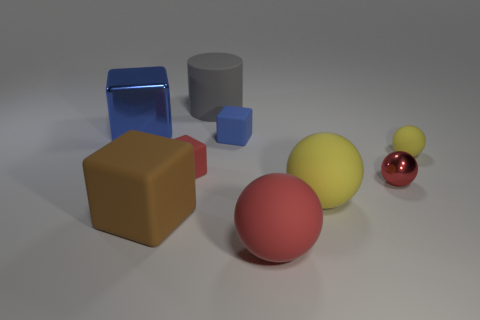Subtract all red metallic spheres. How many spheres are left? 3 Add 1 big blue objects. How many objects exist? 10 Subtract all gray cubes. How many red spheres are left? 2 Subtract all red spheres. How many spheres are left? 2 Subtract all cylinders. How many objects are left? 8 Subtract 4 blocks. How many blocks are left? 0 Subtract all small rubber cubes. Subtract all yellow objects. How many objects are left? 5 Add 9 big yellow balls. How many big yellow balls are left? 10 Add 8 green cubes. How many green cubes exist? 8 Subtract 1 blue cubes. How many objects are left? 8 